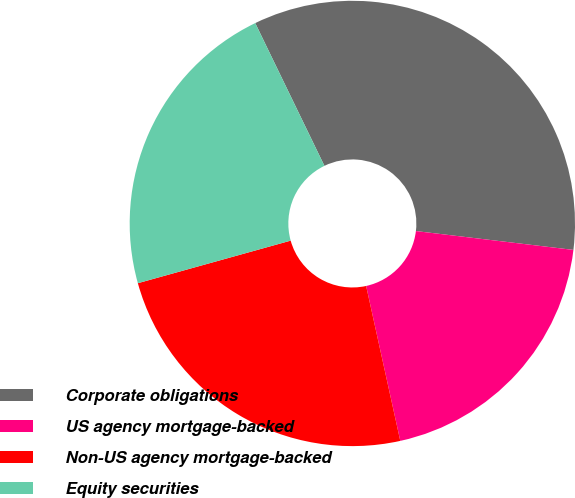Convert chart to OTSL. <chart><loc_0><loc_0><loc_500><loc_500><pie_chart><fcel>Corporate obligations<fcel>US agency mortgage-backed<fcel>Non-US agency mortgage-backed<fcel>Equity securities<nl><fcel>34.08%<fcel>19.65%<fcel>24.13%<fcel>22.14%<nl></chart> 